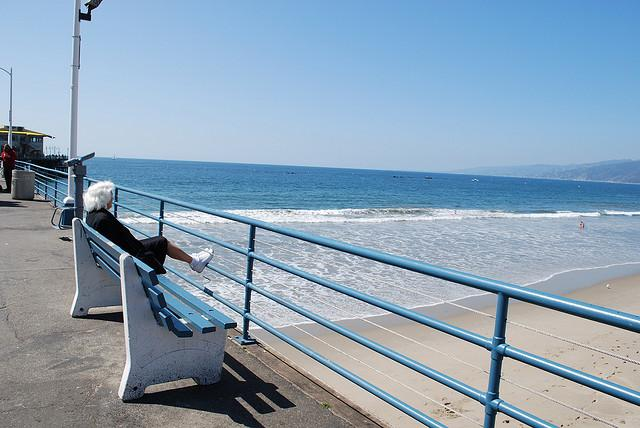What is the name of the structure the bench is sitting on? Please explain your reasoning. pier. The structure is raised and surrounded by water as it extends out. these features are consistent with answer a. 